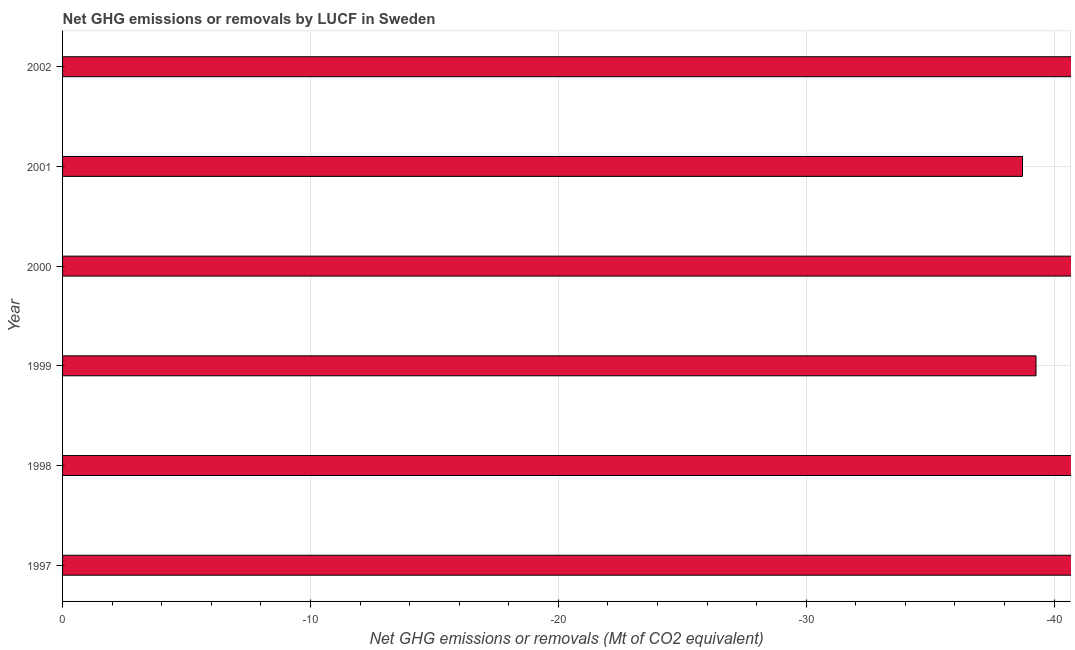What is the title of the graph?
Keep it short and to the point. Net GHG emissions or removals by LUCF in Sweden. What is the label or title of the X-axis?
Keep it short and to the point. Net GHG emissions or removals (Mt of CO2 equivalent). What is the ghg net emissions or removals in 1997?
Offer a very short reply. 0. Across all years, what is the minimum ghg net emissions or removals?
Provide a succinct answer. 0. What is the sum of the ghg net emissions or removals?
Provide a succinct answer. 0. In how many years, is the ghg net emissions or removals greater than the average ghg net emissions or removals taken over all years?
Make the answer very short. 0. How many bars are there?
Your answer should be compact. 0. What is the difference between two consecutive major ticks on the X-axis?
Give a very brief answer. 10. What is the Net GHG emissions or removals (Mt of CO2 equivalent) of 1997?
Ensure brevity in your answer.  0. What is the Net GHG emissions or removals (Mt of CO2 equivalent) of 2000?
Offer a terse response. 0. What is the Net GHG emissions or removals (Mt of CO2 equivalent) of 2002?
Give a very brief answer. 0. 